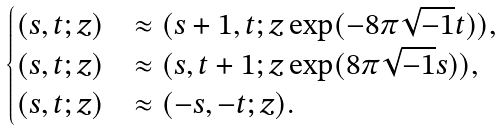Convert formula to latex. <formula><loc_0><loc_0><loc_500><loc_500>\begin{cases} ( s , t ; z ) & \approx ( s + 1 , t ; z \exp ( - 8 \pi \sqrt { - 1 } t ) ) , \\ ( s , t ; z ) & \approx ( s , t + 1 ; z \exp ( 8 \pi \sqrt { - 1 } s ) ) , \\ ( s , t ; z ) & \approx ( - s , - t ; z ) . \end{cases}</formula> 